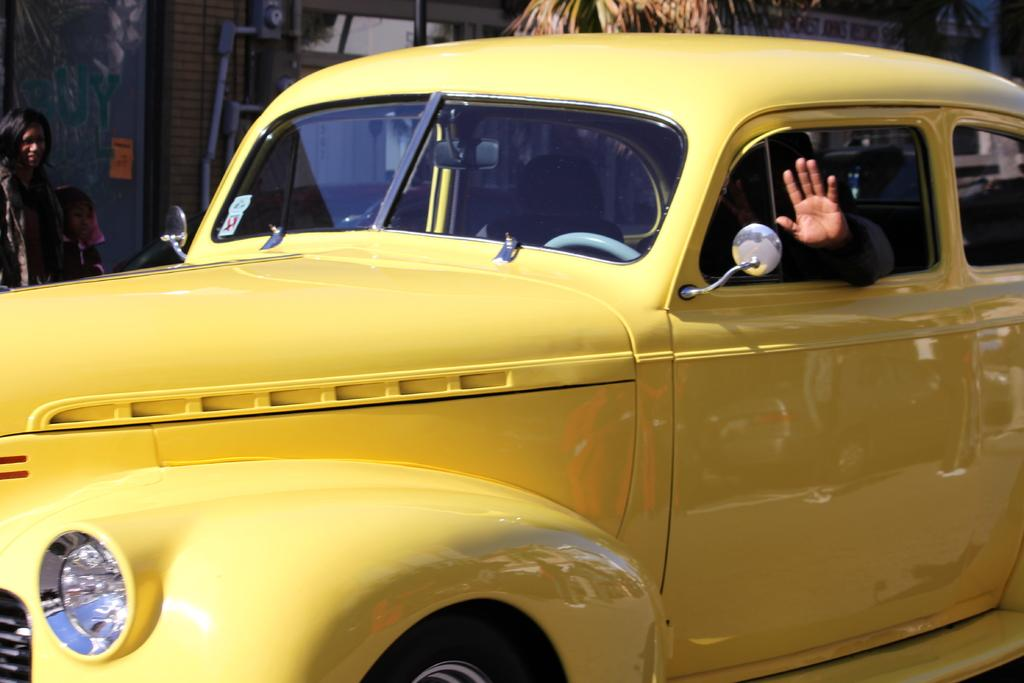What is the person in the image doing? The person is in a yellow vehicle in the image. How many people are standing in the image? There are two people standing in the image. What can be seen in the background of the image? There are trees and a building in the background of the image. How many snakes are slithering on the ground in the image? There are no snakes present in the image. What is the distance between the two people standing in the image? The distance between the two people cannot be determined from the image alone, as there is no reference point for measurement. 